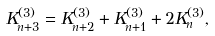Convert formula to latex. <formula><loc_0><loc_0><loc_500><loc_500>K _ { n + 3 } ^ { ( 3 ) } = K _ { n + 2 } ^ { ( 3 ) } + K _ { n + 1 } ^ { ( 3 ) } + 2 K _ { n } ^ { ( 3 ) } ,</formula> 